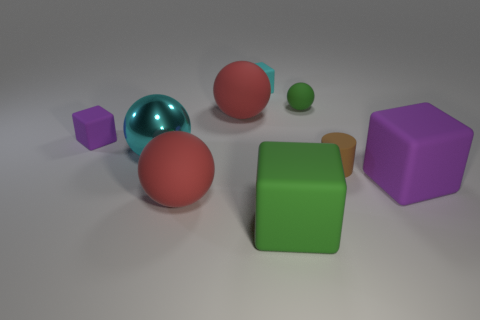Subtract all tiny rubber balls. How many balls are left? 3 Subtract all cyan blocks. How many blocks are left? 3 Add 1 tiny blue cubes. How many objects exist? 10 Subtract 2 balls. How many balls are left? 2 Subtract all red blocks. How many red spheres are left? 2 Subtract all small blue metallic spheres. Subtract all large green matte blocks. How many objects are left? 8 Add 7 metallic things. How many metallic things are left? 8 Add 8 brown things. How many brown things exist? 9 Subtract 1 red spheres. How many objects are left? 8 Subtract all spheres. How many objects are left? 5 